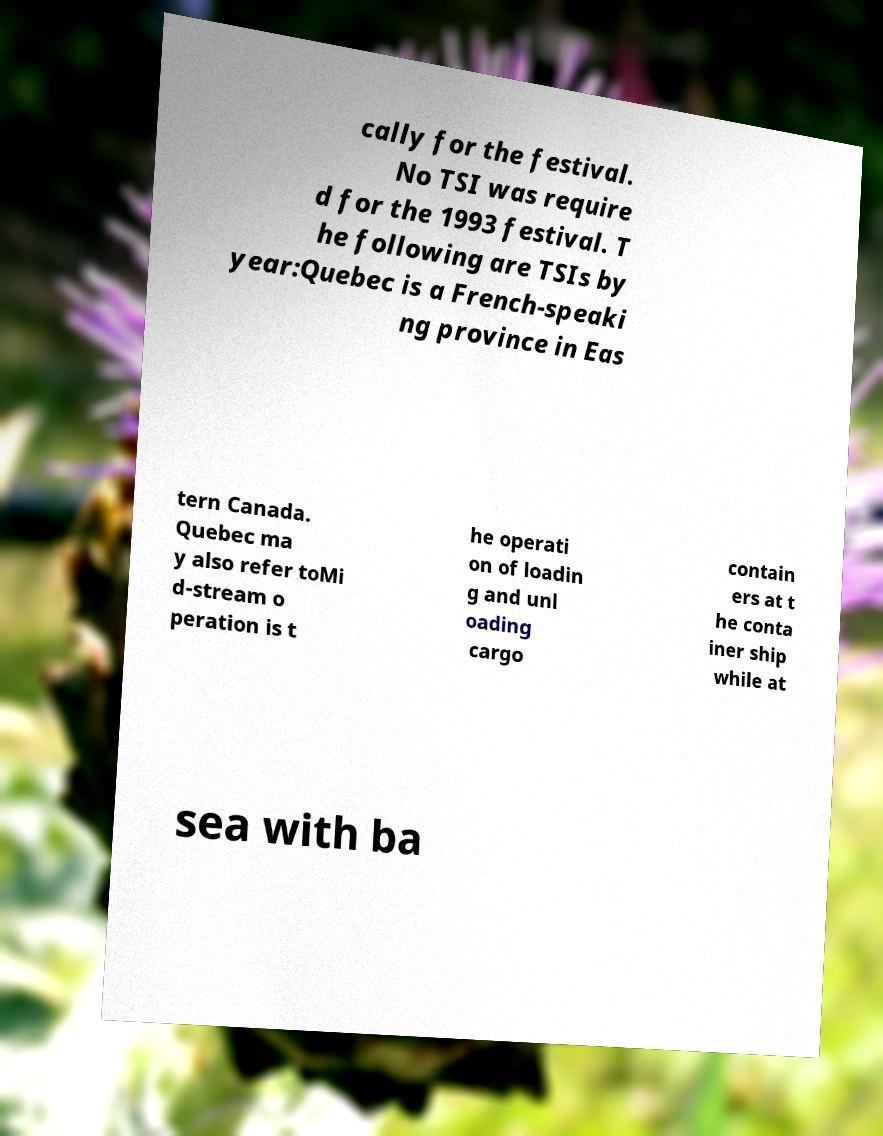Could you assist in decoding the text presented in this image and type it out clearly? cally for the festival. No TSI was require d for the 1993 festival. T he following are TSIs by year:Quebec is a French-speaki ng province in Eas tern Canada. Quebec ma y also refer toMi d-stream o peration is t he operati on of loadin g and unl oading cargo contain ers at t he conta iner ship while at sea with ba 